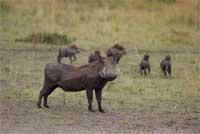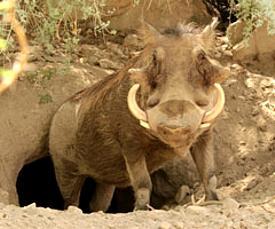The first image is the image on the left, the second image is the image on the right. Examine the images to the left and right. Is the description "There are no more than two warthogs in the image on the right." accurate? Answer yes or no. Yes. 